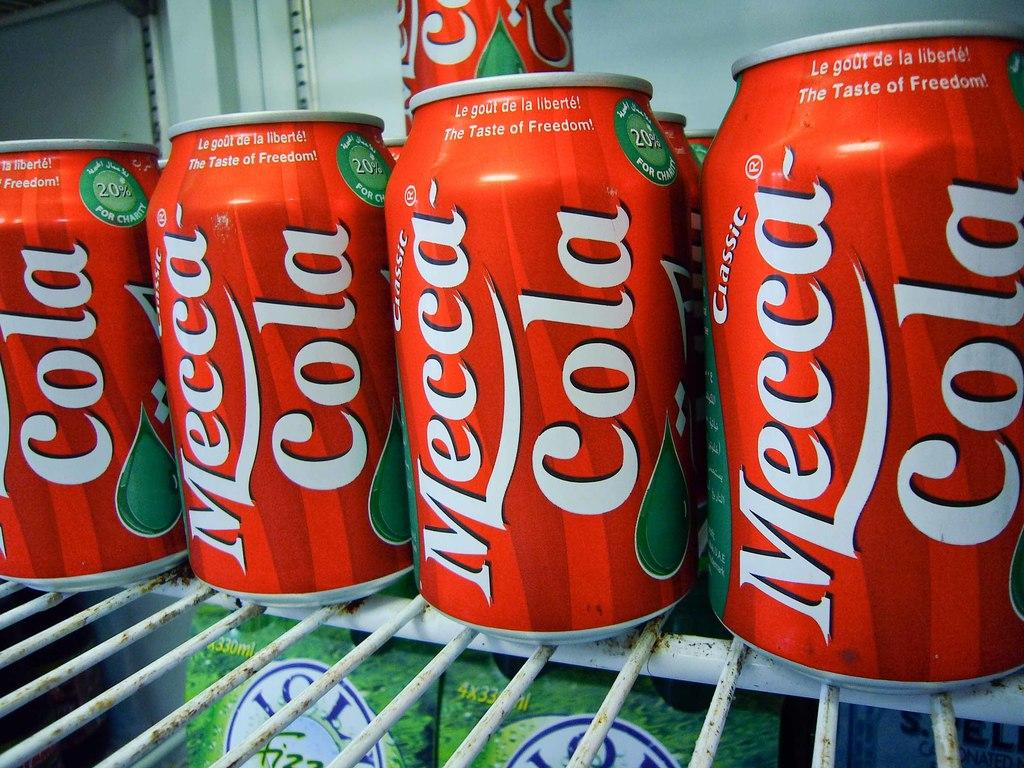<image>
Relay a brief, clear account of the picture shown. Cans of Mecca Cola sit on a white wire shelf. 